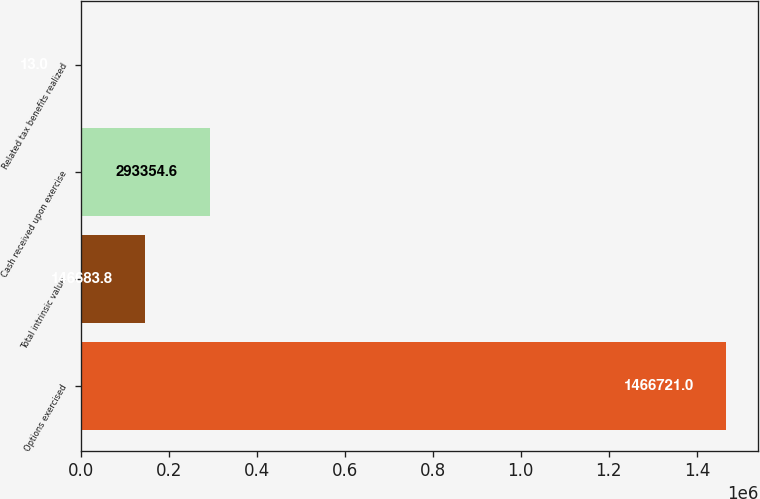<chart> <loc_0><loc_0><loc_500><loc_500><bar_chart><fcel>Options exercised<fcel>Total intrinsic value<fcel>Cash received upon exercise<fcel>Related tax benefits realized<nl><fcel>1.46672e+06<fcel>146684<fcel>293355<fcel>13<nl></chart> 